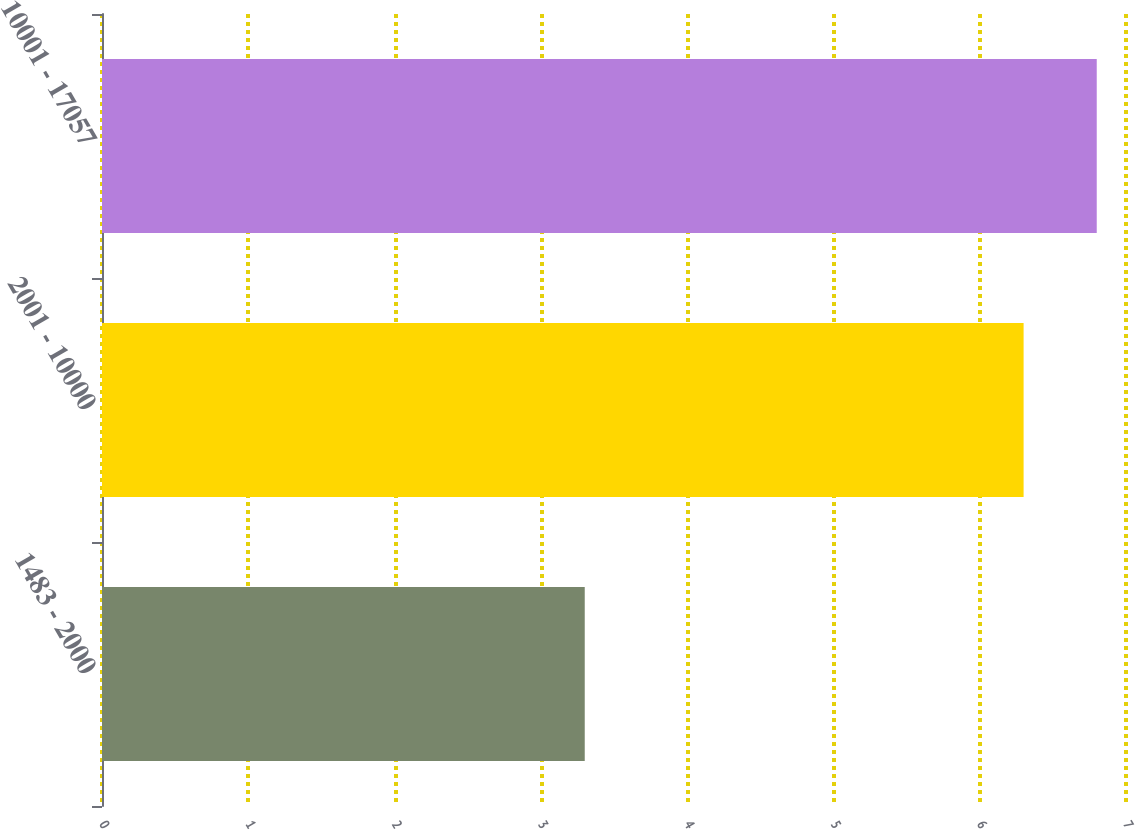Convert chart to OTSL. <chart><loc_0><loc_0><loc_500><loc_500><bar_chart><fcel>1483 - 2000<fcel>2001 - 10000<fcel>10001 - 17057<nl><fcel>3.3<fcel>6.3<fcel>6.8<nl></chart> 